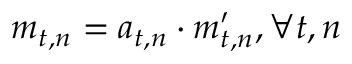Convert formula to latex. <formula><loc_0><loc_0><loc_500><loc_500>m _ { t , n } = a _ { t , n } \cdot m _ { t , n } ^ { \prime } , \forall t , n</formula> 